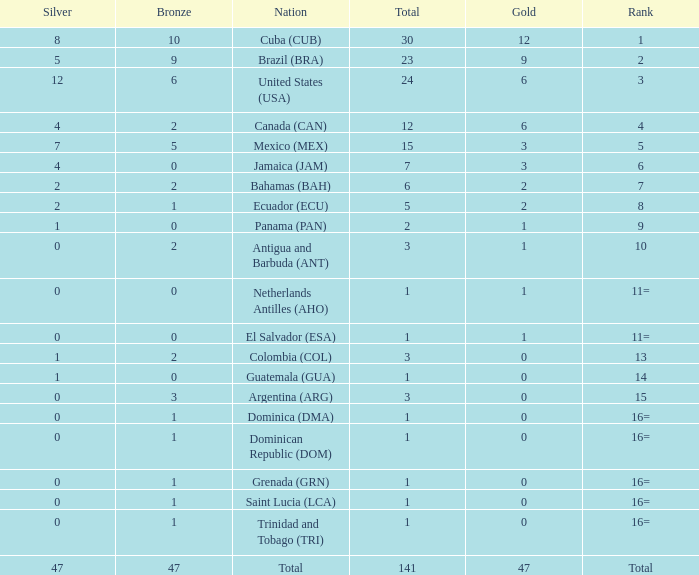How many bronzes have a Nation of jamaica (jam), and a Total smaller than 7? 0.0. Parse the table in full. {'header': ['Silver', 'Bronze', 'Nation', 'Total', 'Gold', 'Rank'], 'rows': [['8', '10', 'Cuba (CUB)', '30', '12', '1'], ['5', '9', 'Brazil (BRA)', '23', '9', '2'], ['12', '6', 'United States (USA)', '24', '6', '3'], ['4', '2', 'Canada (CAN)', '12', '6', '4'], ['7', '5', 'Mexico (MEX)', '15', '3', '5'], ['4', '0', 'Jamaica (JAM)', '7', '3', '6'], ['2', '2', 'Bahamas (BAH)', '6', '2', '7'], ['2', '1', 'Ecuador (ECU)', '5', '2', '8'], ['1', '0', 'Panama (PAN)', '2', '1', '9'], ['0', '2', 'Antigua and Barbuda (ANT)', '3', '1', '10'], ['0', '0', 'Netherlands Antilles (AHO)', '1', '1', '11='], ['0', '0', 'El Salvador (ESA)', '1', '1', '11='], ['1', '2', 'Colombia (COL)', '3', '0', '13'], ['1', '0', 'Guatemala (GUA)', '1', '0', '14'], ['0', '3', 'Argentina (ARG)', '3', '0', '15'], ['0', '1', 'Dominica (DMA)', '1', '0', '16='], ['0', '1', 'Dominican Republic (DOM)', '1', '0', '16='], ['0', '1', 'Grenada (GRN)', '1', '0', '16='], ['0', '1', 'Saint Lucia (LCA)', '1', '0', '16='], ['0', '1', 'Trinidad and Tobago (TRI)', '1', '0', '16='], ['47', '47', 'Total', '141', '47', 'Total']]} 